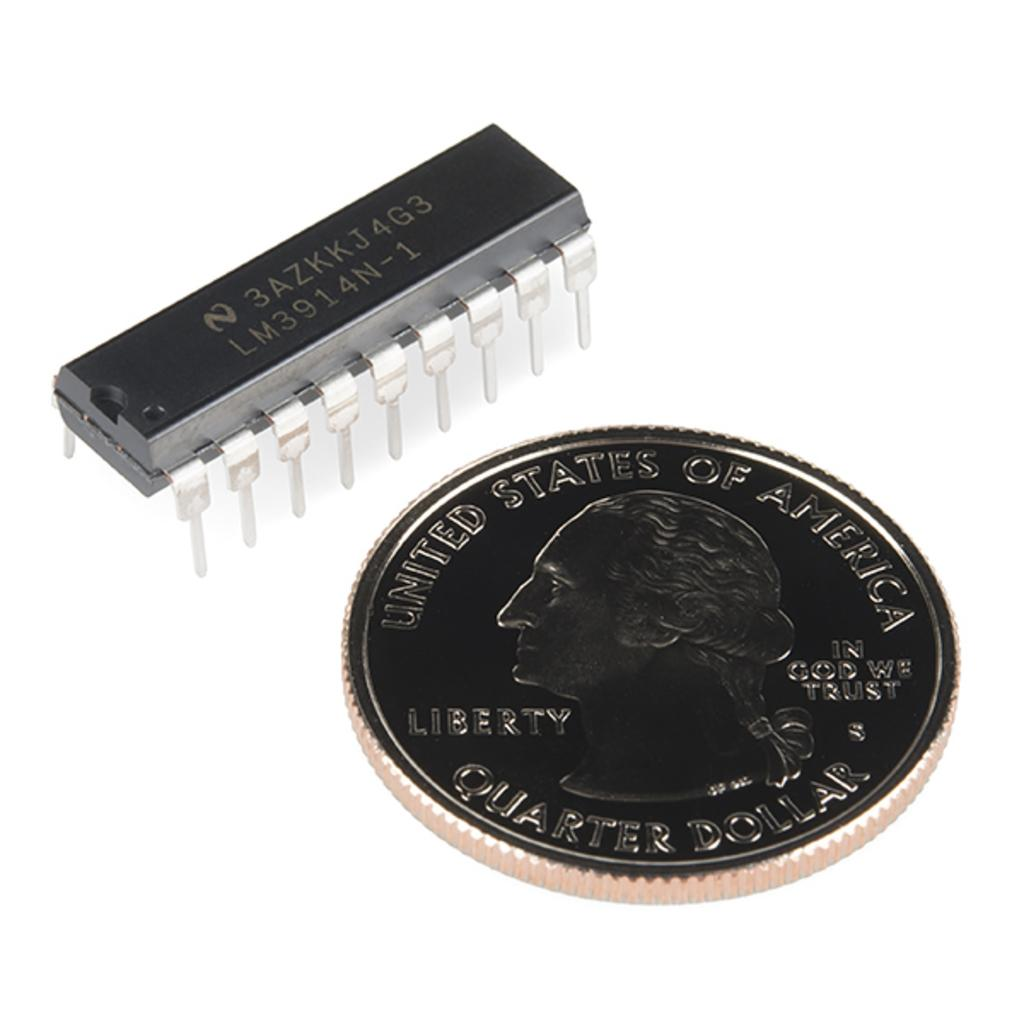<image>
Share a concise interpretation of the image provided. a united states quarter dollar sitting beside a small electronic device. 